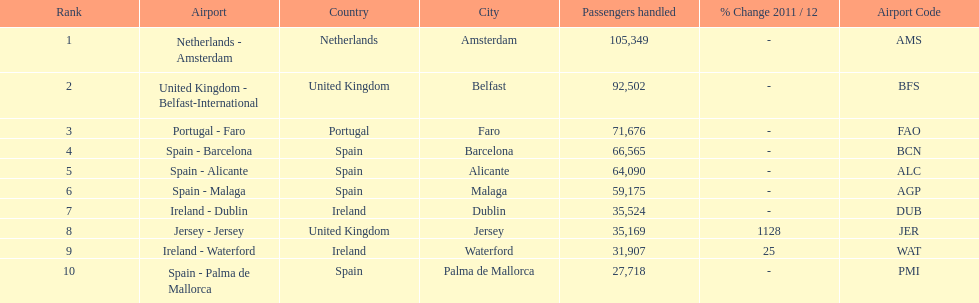Looking at the top 10 busiest routes to and from london southend airport what is the average number of passengers handled? 58,967.5. Would you be able to parse every entry in this table? {'header': ['Rank', 'Airport', 'Country', 'City', 'Passengers handled', '% Change 2011 / 12', 'Airport Code'], 'rows': [['1', 'Netherlands - Amsterdam', 'Netherlands', 'Amsterdam', '105,349', '-', 'AMS'], ['2', 'United Kingdom - Belfast-International', 'United Kingdom', 'Belfast', '92,502', '-', 'BFS'], ['3', 'Portugal - Faro', 'Portugal', 'Faro', '71,676', '-', 'FAO'], ['4', 'Spain - Barcelona', 'Spain', 'Barcelona', '66,565', '-', 'BCN'], ['5', 'Spain - Alicante', 'Spain', 'Alicante', '64,090', '-', 'ALC'], ['6', 'Spain - Malaga', 'Spain', 'Malaga', '59,175', '-', 'AGP'], ['7', 'Ireland - Dublin', 'Ireland', 'Dublin', '35,524', '-', 'DUB'], ['8', 'Jersey - Jersey', 'United Kingdom', 'Jersey', '35,169', '1128', 'JER'], ['9', 'Ireland - Waterford', 'Ireland', 'Waterford', '31,907', '25', 'WAT'], ['10', 'Spain - Palma de Mallorca', 'Spain', 'Palma de Mallorca', '27,718', '-', 'PMI']]} 